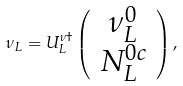Convert formula to latex. <formula><loc_0><loc_0><loc_500><loc_500>\nu _ { L } = U _ { L } ^ { \nu \dag } \left ( \begin{array} { c } \nu _ { L } ^ { 0 } \\ N _ { L } ^ { 0 c } \end{array} \right ) ,</formula> 